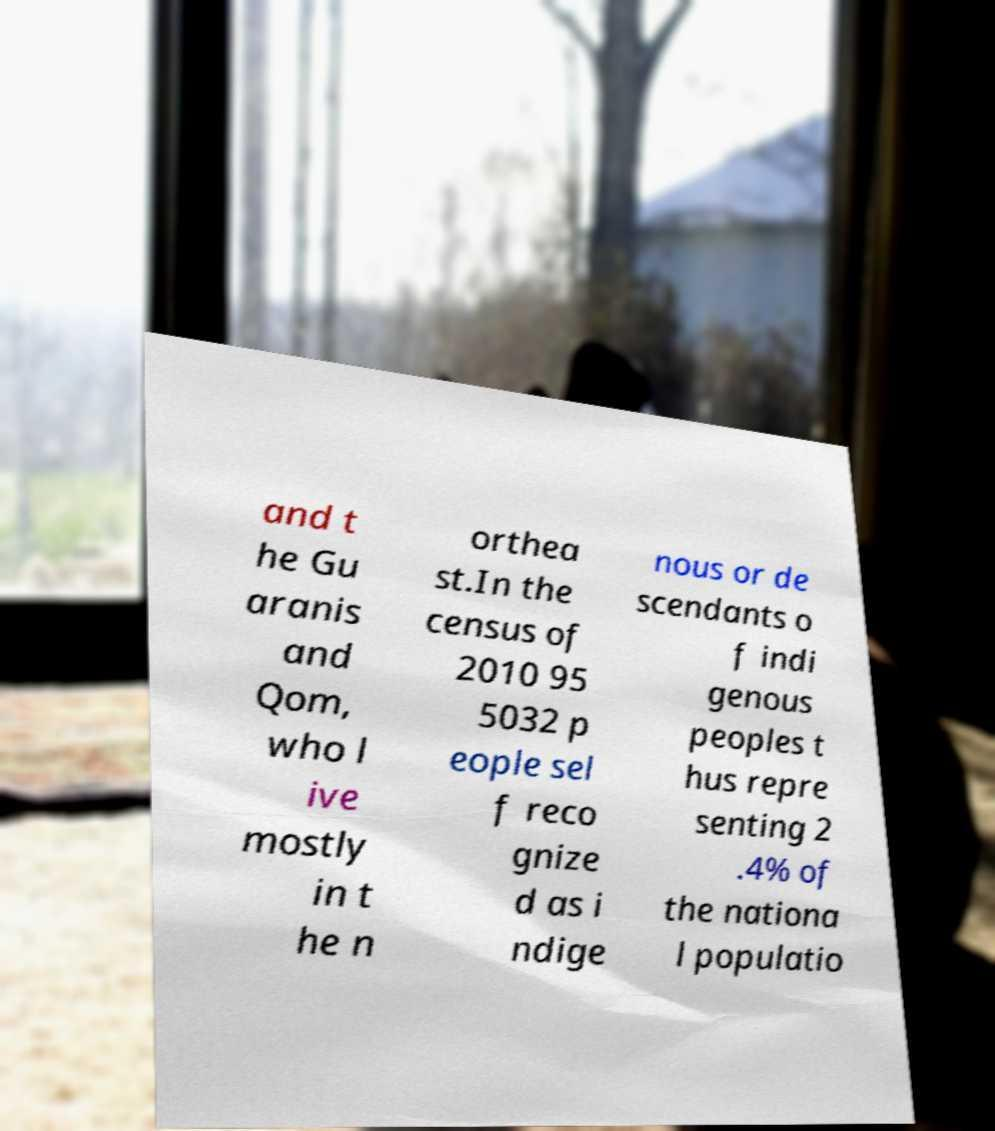Can you read and provide the text displayed in the image?This photo seems to have some interesting text. Can you extract and type it out for me? and t he Gu aranis and Qom, who l ive mostly in t he n orthea st.In the census of 2010 95 5032 p eople sel f reco gnize d as i ndige nous or de scendants o f indi genous peoples t hus repre senting 2 .4% of the nationa l populatio 